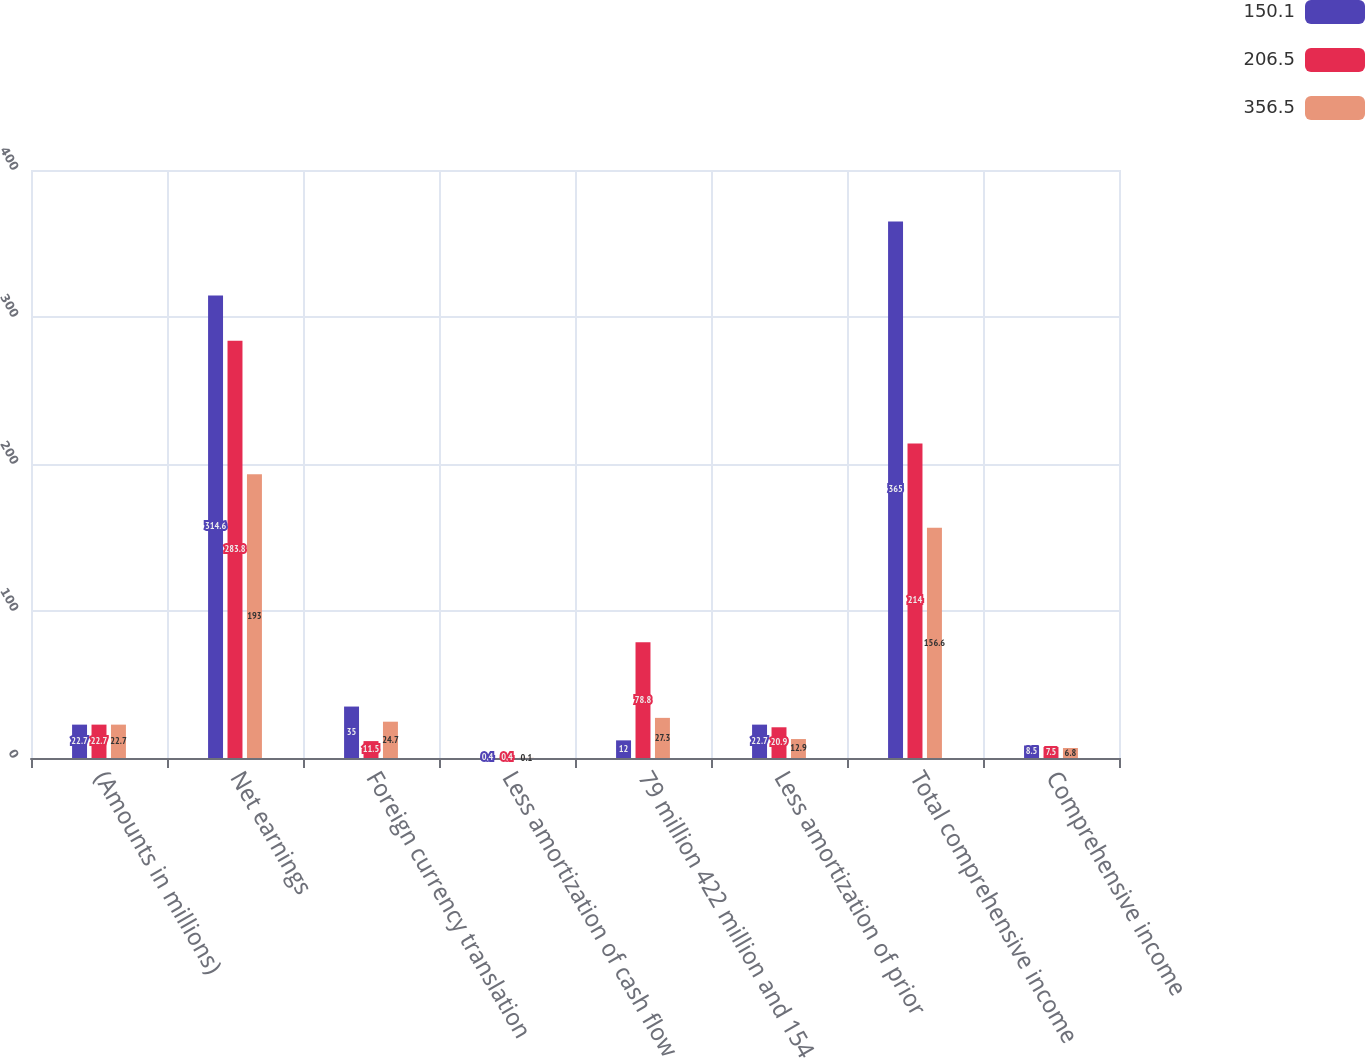<chart> <loc_0><loc_0><loc_500><loc_500><stacked_bar_chart><ecel><fcel>(Amounts in millions)<fcel>Net earnings<fcel>Foreign currency translation<fcel>Less amortization of cash flow<fcel>79 million 422 million and 154<fcel>Less amortization of prior<fcel>Total comprehensive income<fcel>Comprehensive income<nl><fcel>150.1<fcel>22.7<fcel>314.6<fcel>35<fcel>0.4<fcel>12<fcel>22.7<fcel>365<fcel>8.5<nl><fcel>206.5<fcel>22.7<fcel>283.8<fcel>11.5<fcel>0.4<fcel>78.8<fcel>20.9<fcel>214<fcel>7.5<nl><fcel>356.5<fcel>22.7<fcel>193<fcel>24.7<fcel>0.1<fcel>27.3<fcel>12.9<fcel>156.6<fcel>6.8<nl></chart> 